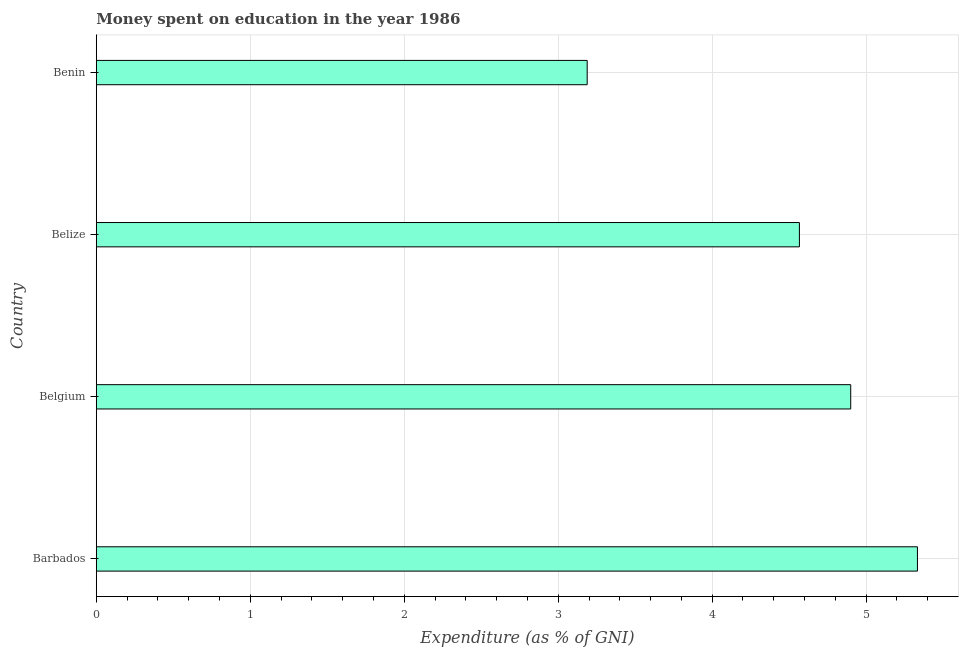What is the title of the graph?
Offer a very short reply. Money spent on education in the year 1986. What is the label or title of the X-axis?
Make the answer very short. Expenditure (as % of GNI). Across all countries, what is the maximum expenditure on education?
Give a very brief answer. 5.33. Across all countries, what is the minimum expenditure on education?
Keep it short and to the point. 3.19. In which country was the expenditure on education maximum?
Your answer should be very brief. Barbados. In which country was the expenditure on education minimum?
Provide a short and direct response. Benin. What is the sum of the expenditure on education?
Offer a terse response. 17.99. What is the difference between the expenditure on education in Belgium and Benin?
Your answer should be very brief. 1.71. What is the average expenditure on education per country?
Your answer should be compact. 4.5. What is the median expenditure on education?
Your answer should be compact. 4.73. What is the ratio of the expenditure on education in Barbados to that in Benin?
Offer a terse response. 1.67. What is the difference between the highest and the second highest expenditure on education?
Give a very brief answer. 0.43. Is the sum of the expenditure on education in Belize and Benin greater than the maximum expenditure on education across all countries?
Make the answer very short. Yes. What is the difference between the highest and the lowest expenditure on education?
Your answer should be compact. 2.15. Are all the bars in the graph horizontal?
Provide a succinct answer. Yes. Are the values on the major ticks of X-axis written in scientific E-notation?
Ensure brevity in your answer.  No. What is the Expenditure (as % of GNI) of Barbados?
Make the answer very short. 5.33. What is the Expenditure (as % of GNI) in Belgium?
Make the answer very short. 4.9. What is the Expenditure (as % of GNI) in Belize?
Provide a succinct answer. 4.57. What is the Expenditure (as % of GNI) in Benin?
Offer a terse response. 3.19. What is the difference between the Expenditure (as % of GNI) in Barbados and Belgium?
Your answer should be very brief. 0.43. What is the difference between the Expenditure (as % of GNI) in Barbados and Belize?
Provide a succinct answer. 0.77. What is the difference between the Expenditure (as % of GNI) in Barbados and Benin?
Offer a very short reply. 2.15. What is the difference between the Expenditure (as % of GNI) in Belgium and Belize?
Keep it short and to the point. 0.33. What is the difference between the Expenditure (as % of GNI) in Belgium and Benin?
Your answer should be compact. 1.71. What is the difference between the Expenditure (as % of GNI) in Belize and Benin?
Your answer should be very brief. 1.38. What is the ratio of the Expenditure (as % of GNI) in Barbados to that in Belgium?
Your answer should be compact. 1.09. What is the ratio of the Expenditure (as % of GNI) in Barbados to that in Belize?
Offer a terse response. 1.17. What is the ratio of the Expenditure (as % of GNI) in Barbados to that in Benin?
Give a very brief answer. 1.67. What is the ratio of the Expenditure (as % of GNI) in Belgium to that in Belize?
Offer a very short reply. 1.07. What is the ratio of the Expenditure (as % of GNI) in Belgium to that in Benin?
Give a very brief answer. 1.54. What is the ratio of the Expenditure (as % of GNI) in Belize to that in Benin?
Provide a short and direct response. 1.43. 